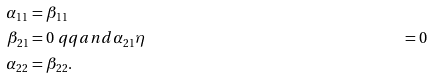<formula> <loc_0><loc_0><loc_500><loc_500>\alpha _ { 1 1 } & = \beta _ { 1 1 } \\ \beta _ { 2 1 } & = 0 \ q q a n d \alpha _ { 2 1 } \eta & = 0 \\ \alpha _ { 2 2 } & = \beta _ { 2 2 } .</formula> 